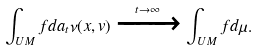Convert formula to latex. <formula><loc_0><loc_0><loc_500><loc_500>\int _ { U M } f d a _ { t } \nu ( x , v ) \xrightarrow { t \rightarrow \infty } \int _ { U M } f d \mu .</formula> 